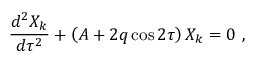Convert formula to latex. <formula><loc_0><loc_0><loc_500><loc_500>{ \frac { d ^ { 2 } X _ { k } } { d \tau ^ { 2 } } } + \left ( A + 2 q \cos 2 \tau \right ) X _ { k } = 0 \ ,</formula> 